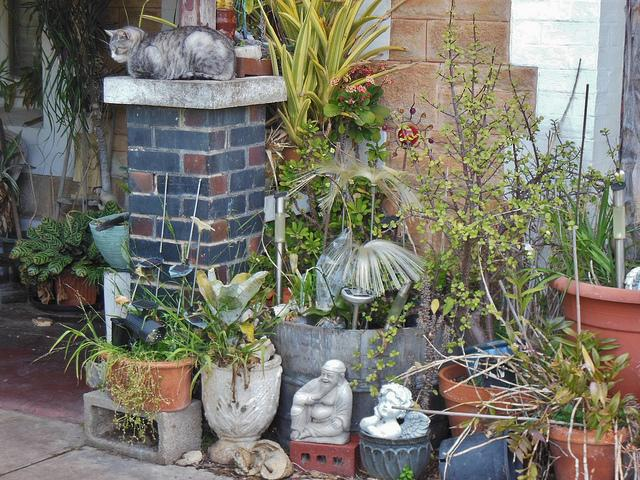What is the little angel in the flower pot called? Please explain your reasoning. cherub. The angel is a cherub. 